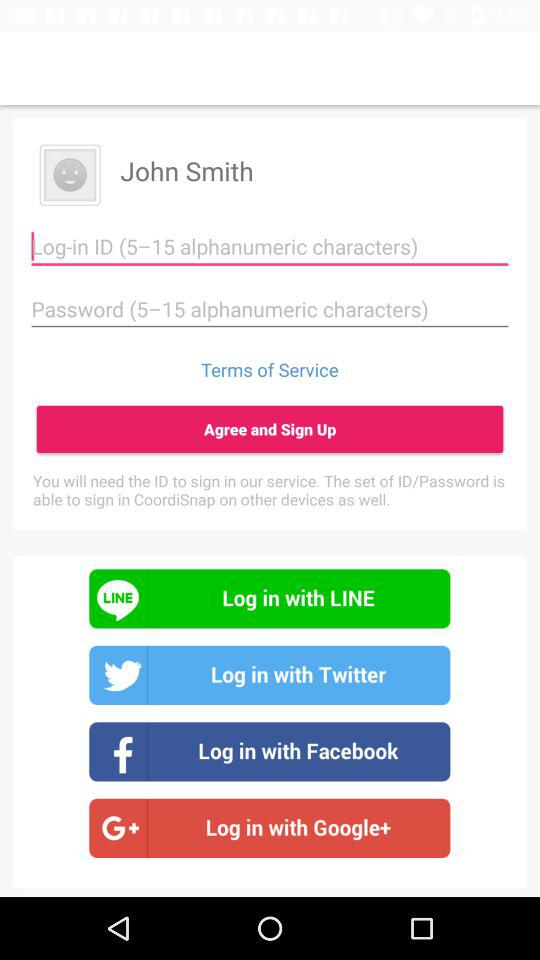Which other applications can be used to sign up? The applications are "LINE", "Twitter", "Facebook" and "Google+". 